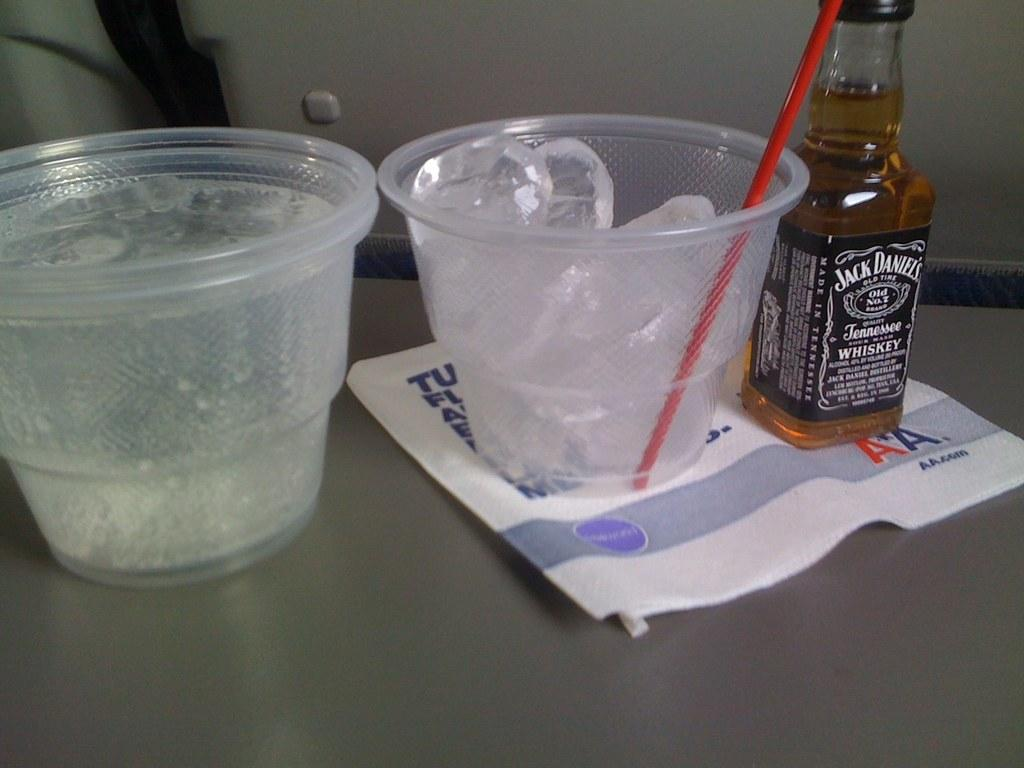<image>
Render a clear and concise summary of the photo. A small bottle of jack daniels whiskey next to a small plastic cup. 